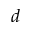<formula> <loc_0><loc_0><loc_500><loc_500>d</formula> 